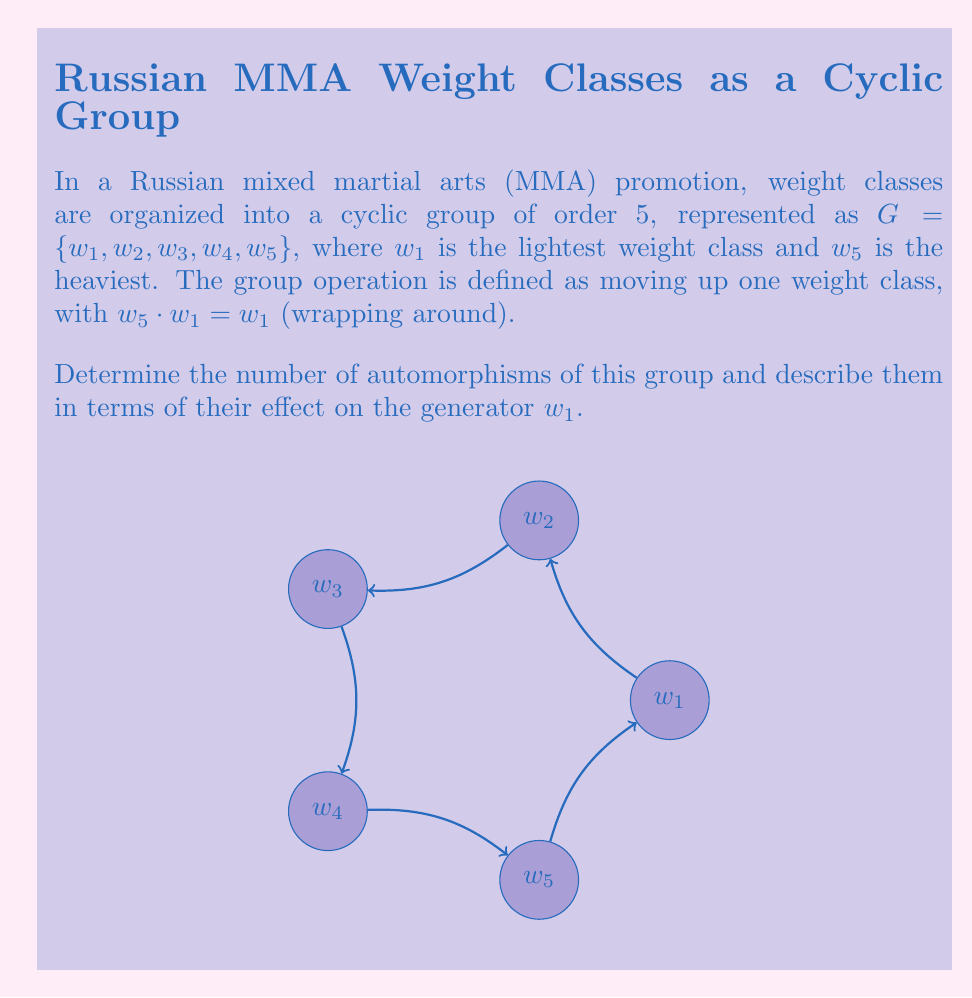Solve this math problem. Let's approach this step-by-step:

1) First, recall that for a cyclic group of order $n$, the number of automorphisms is $\phi(n)$, where $\phi$ is Euler's totient function.

2) In this case, $n = 5$. Since 5 is prime, $\phi(5) = 4$.

3) Now, let's describe these automorphisms. An automorphism of a cyclic group is completely determined by where it sends a generator. In this case, $w_1$ is a generator.

4) The automorphisms must map $w_1$ to another generator of the group. The generators of a cyclic group of order 5 are the elements of order 5, which are all elements except the identity.

5) Therefore, the possible automorphisms are:

   $f_1: w_1 \mapsto w_1$ (identity automorphism)
   $f_2: w_1 \mapsto w_2$
   $f_3: w_1 \mapsto w_3$
   $f_4: w_1 \mapsto w_4$

6) Note that mapping $w_1$ to $w_5$ would be the same as $f_4$, as $w_5 = w_1^4$ in the group.

7) These automorphisms can be thought of as "rotations" of the weight classes, preserving the cyclic structure.
Answer: 4 automorphisms: $f_1(w_1) = w_1$, $f_2(w_1) = w_2$, $f_3(w_1) = w_3$, $f_4(w_1) = w_4$ 